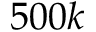Convert formula to latex. <formula><loc_0><loc_0><loc_500><loc_500>5 0 0 k</formula> 